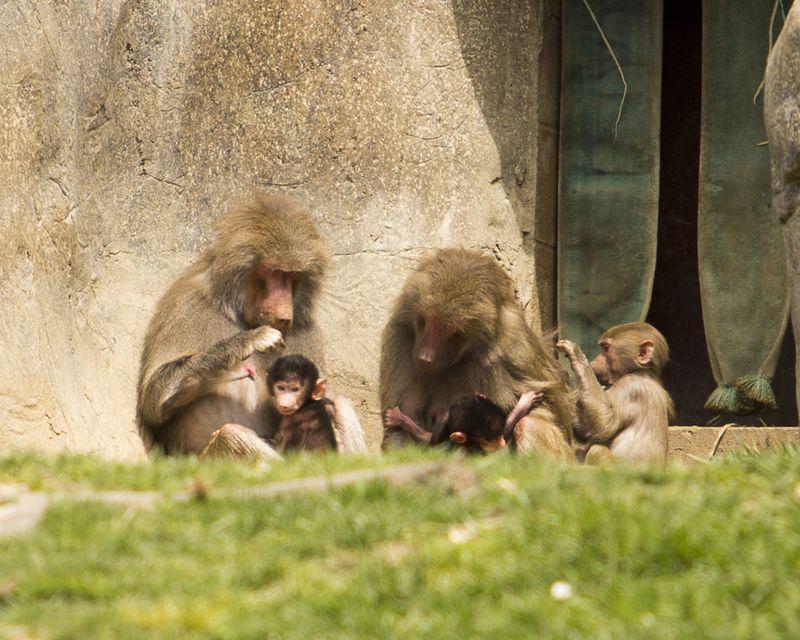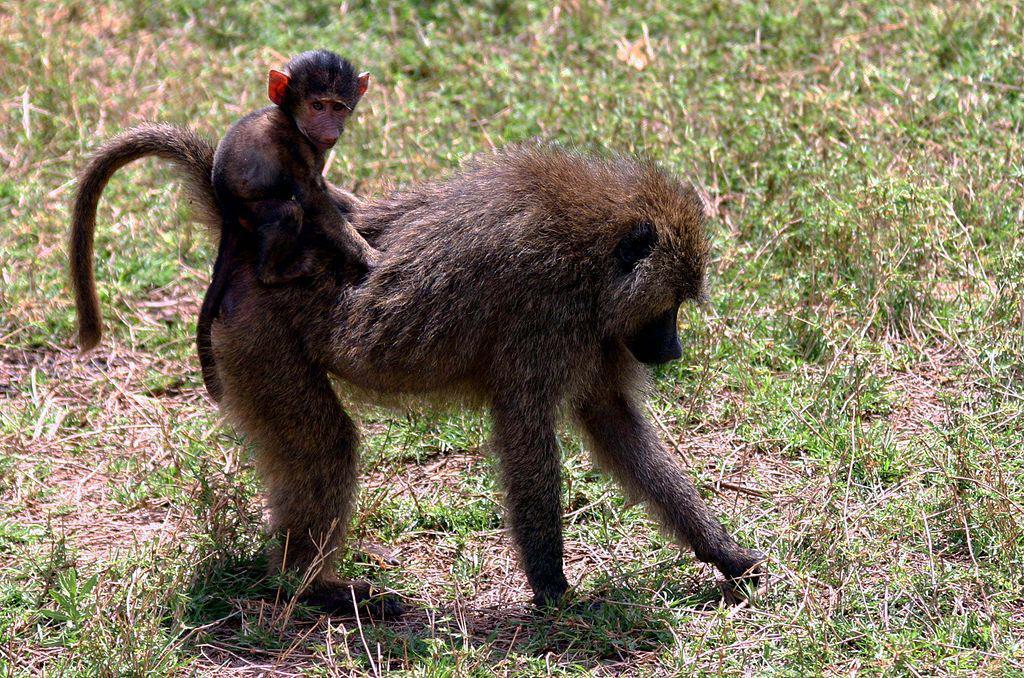The first image is the image on the left, the second image is the image on the right. Given the left and right images, does the statement "One image shows a baby baboon riding on the body of a baboon in profile on all fours." hold true? Answer yes or no. Yes. The first image is the image on the left, the second image is the image on the right. For the images shown, is this caption "The left image contains no more than two primates." true? Answer yes or no. No. 